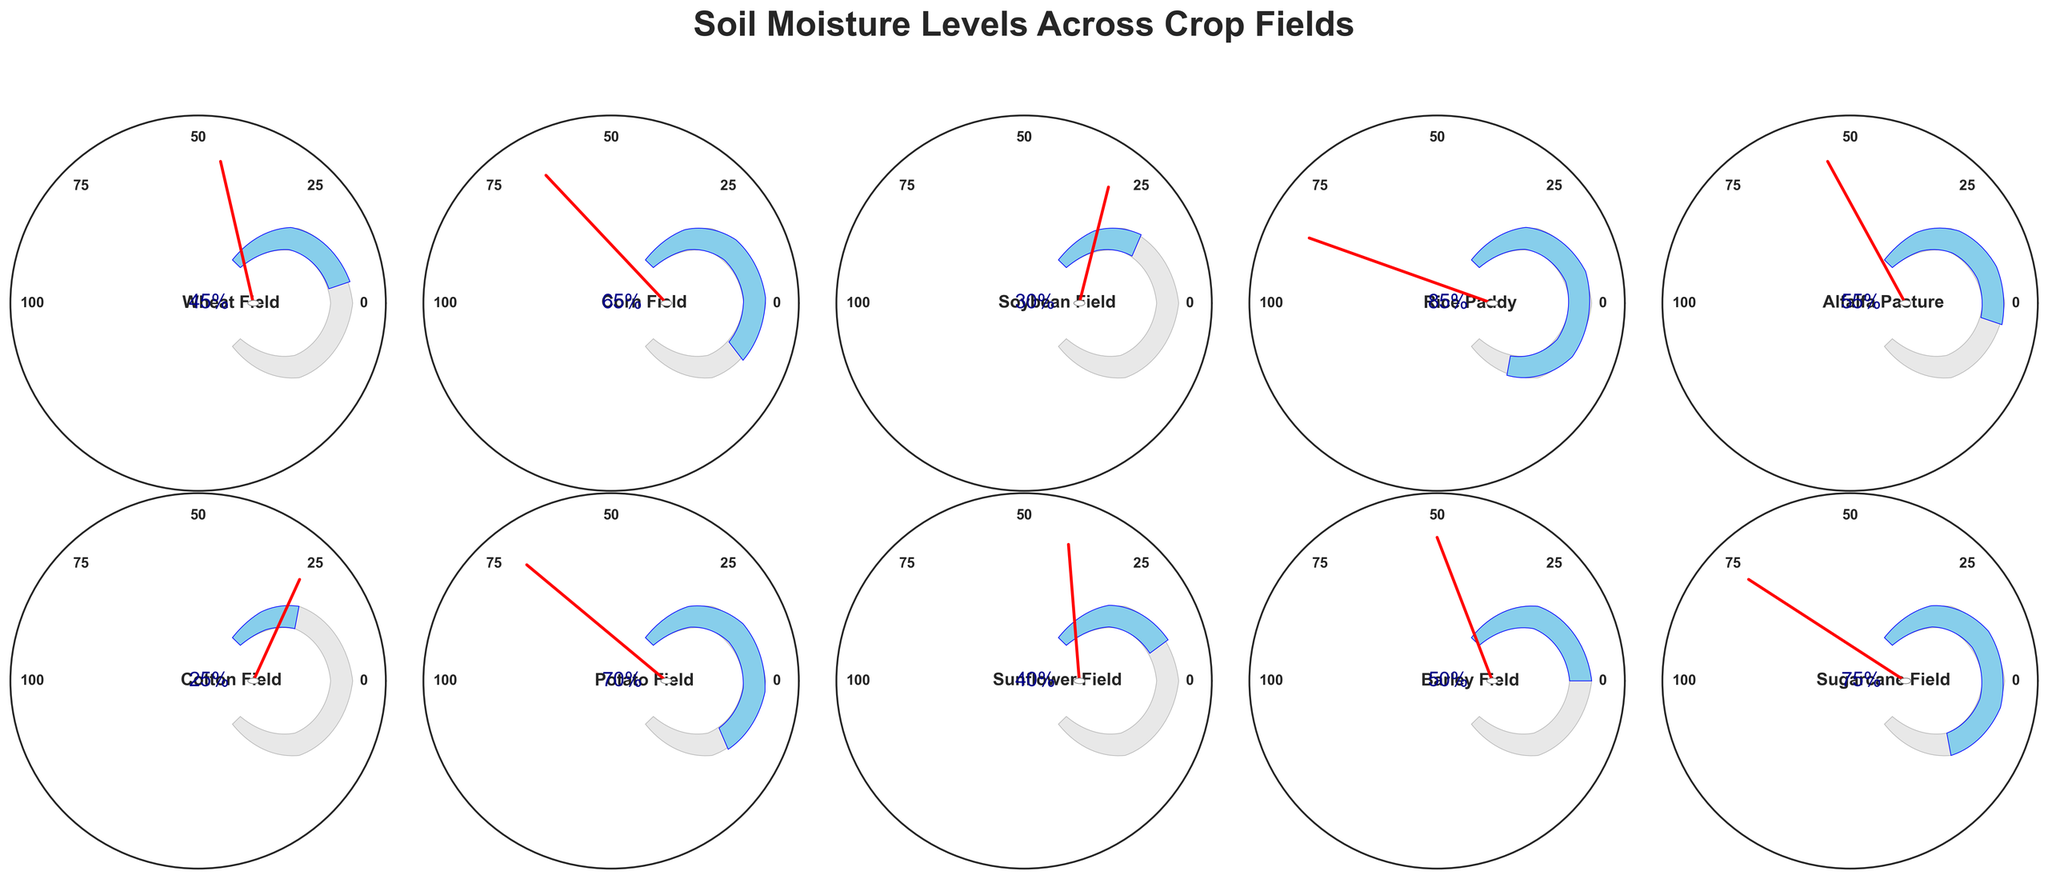What is the soil moisture level of the Corn Field? The Corn Field gauge shows the soil moisture level, which is the number next to the field name. It is indicated as a percentage.
Answer: 65% Which field has the lowest soil moisture level? To find the field with the lowest moisture level, look at all the gauges and identify the one with the smallest percentage value. The Cotton Field has the lowest moisture level at 25%.
Answer: Cotton Field Which field has a higher moisture level, the Rice Paddy or the Sunflower Field? Compare the moisture levels indicated for the Rice Paddy and the Sunflower Field. The Rice Paddy has a moisture level of 85% while the Sunflower Field has a moisture level of 40%. Therefore, the Rice Paddy has a higher moisture level.
Answer: Rice Paddy What is the median soil moisture level of the given fields? The median is the middle value when all the moisture levels are ordered. Arrange the moisture values (25, 30, 40, 45, 50, 55, 65, 70, 75, 85) and find the middle value. Since there is an even number of values, calculate the average of the 5th and 6th values: (50 + 55) / 2 = 52.5.
Answer: 52.5% How many fields have a moisture level above 70%? Look at the gauges and count the fields where the moisture percentage is above 70%. The fields are Rice Paddy and Sugarcane Field.
Answer: 2 Which field has a slightly higher moisture level, the Alfalfa Pasture or the Barley Field? Compare the moisture levels of Alfalfa Pasture and Barley Field. Alfalfa Pasture has 55% and Barley Field has 50%. Thus, Alfalfa Pasture has a slightly higher moisture level.
Answer: Alfalfa Pasture What is the average soil moisture level across all fields? Sum all soil moisture levels and divide by the number of fields: (45 + 65 + 30 + 85 + 55 + 25 + 70 + 40 + 50 + 75) / 10 = 540 / 10 = 54.
Answer: 54% Which field has a moisture level closest to the average soil moisture across all fields? The average soil moisture level is 54%. Comparing each field's level to this value, Alfalfa Pasture's moisture level of 55% is the closest.
Answer: Alfalfa Pasture Which two fields have the most similar soil moisture levels? Look for pairs of fields with the smallest difference in their moisture levels: Wheat Field (45%) and Barley Field (50%) have a difference of just 5%.
Answer: Wheat Field and Barley Field What is the range of soil moisture levels among all fields? The range is calculated as the difference between the maximum and minimum values. The highest is 85% (Rice Paddy) and the lowest is 25% (Cotton Field). Thus, the range is 85% - 25% = 60%.
Answer: 60% 